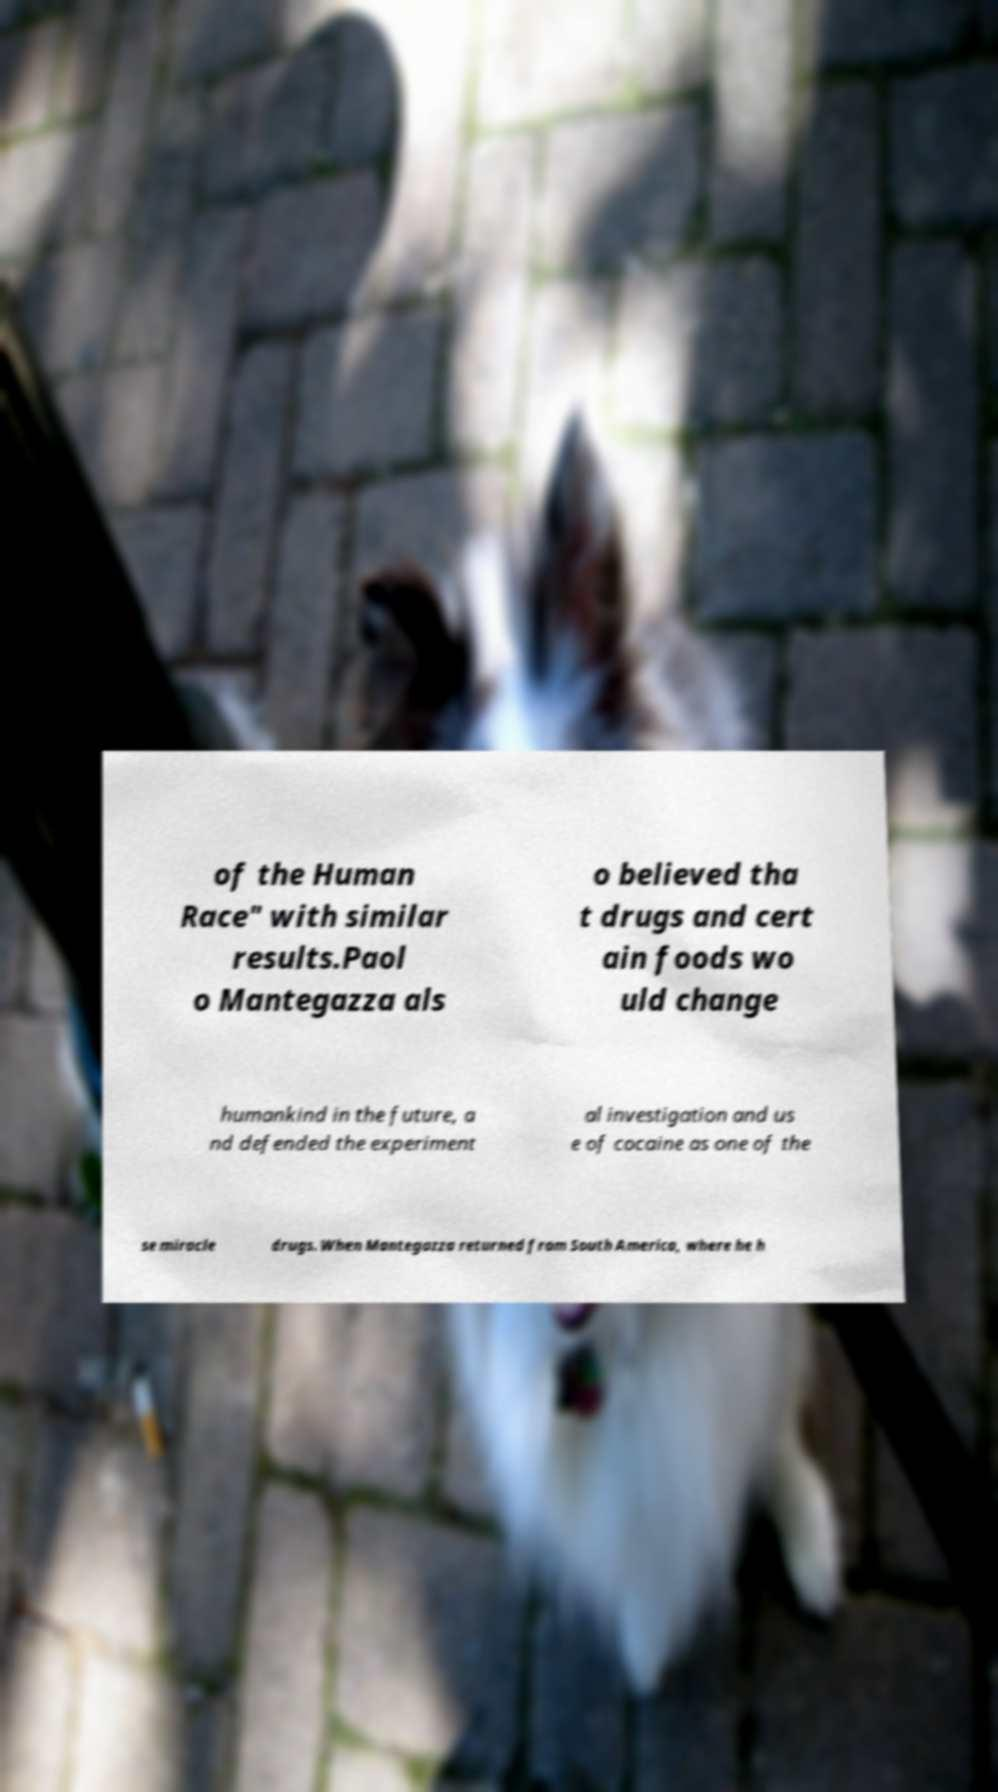I need the written content from this picture converted into text. Can you do that? of the Human Race" with similar results.Paol o Mantegazza als o believed tha t drugs and cert ain foods wo uld change humankind in the future, a nd defended the experiment al investigation and us e of cocaine as one of the se miracle drugs. When Mantegazza returned from South America, where he h 